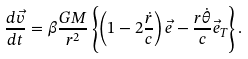Convert formula to latex. <formula><loc_0><loc_0><loc_500><loc_500>\frac { d \vec { v } } { d t } = \beta \frac { G M } { r ^ { 2 } } \left \{ \left ( 1 - 2 \frac { \dot { r } } { c } \right ) \vec { e } - \frac { r \dot { \theta } } { c } \vec { e } _ { T } \right \} .</formula> 